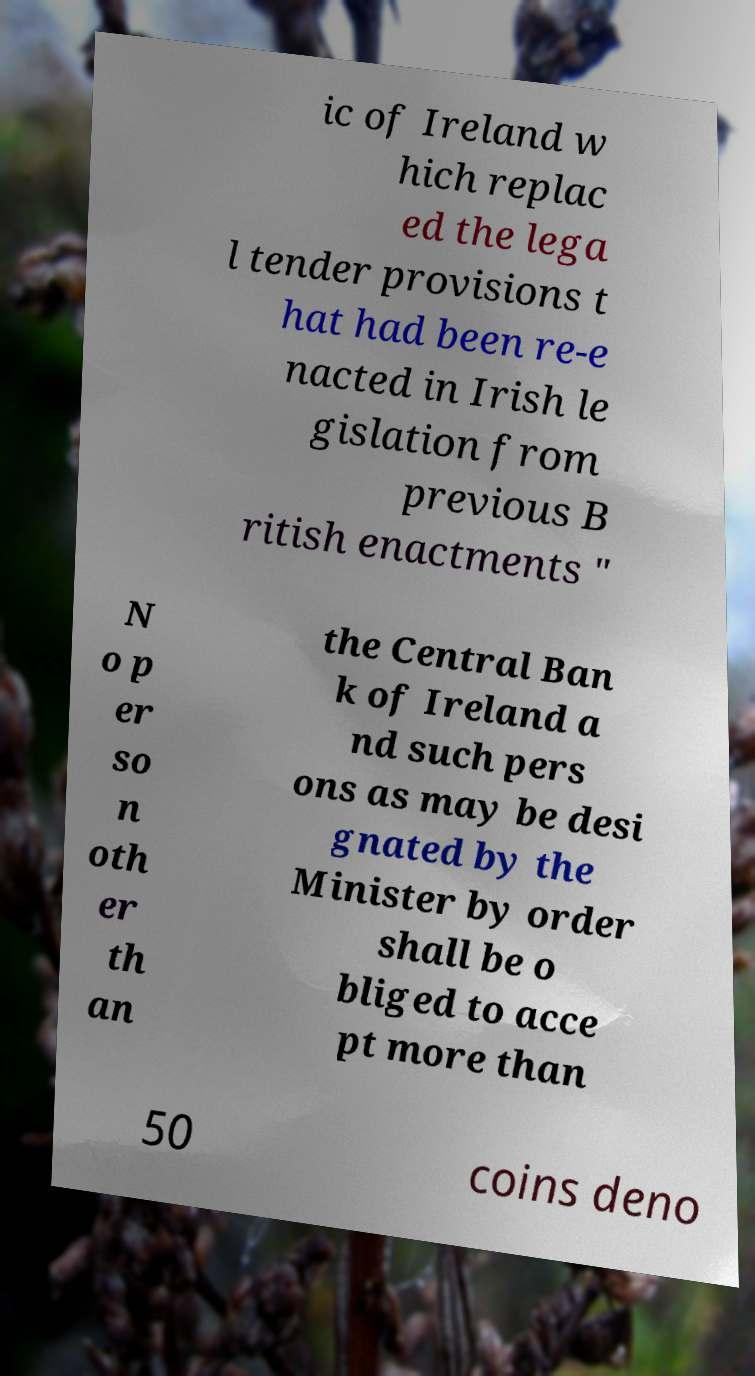Please identify and transcribe the text found in this image. ic of Ireland w hich replac ed the lega l tender provisions t hat had been re-e nacted in Irish le gislation from previous B ritish enactments " N o p er so n oth er th an the Central Ban k of Ireland a nd such pers ons as may be desi gnated by the Minister by order shall be o bliged to acce pt more than 50 coins deno 